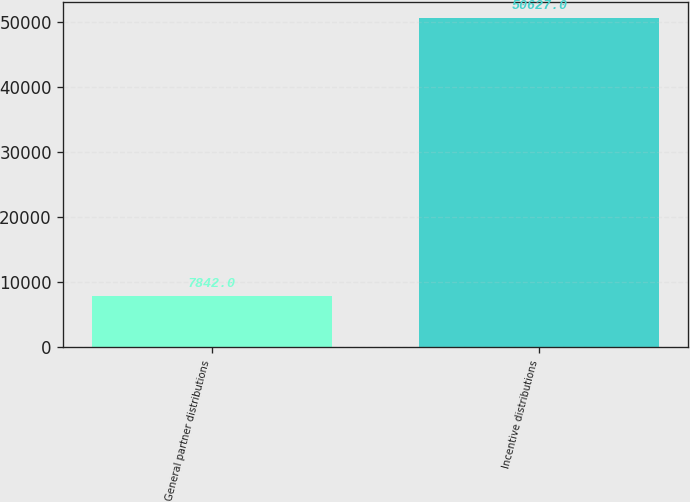Convert chart. <chart><loc_0><loc_0><loc_500><loc_500><bar_chart><fcel>General partner distributions<fcel>Incentive distributions<nl><fcel>7842<fcel>50627<nl></chart> 